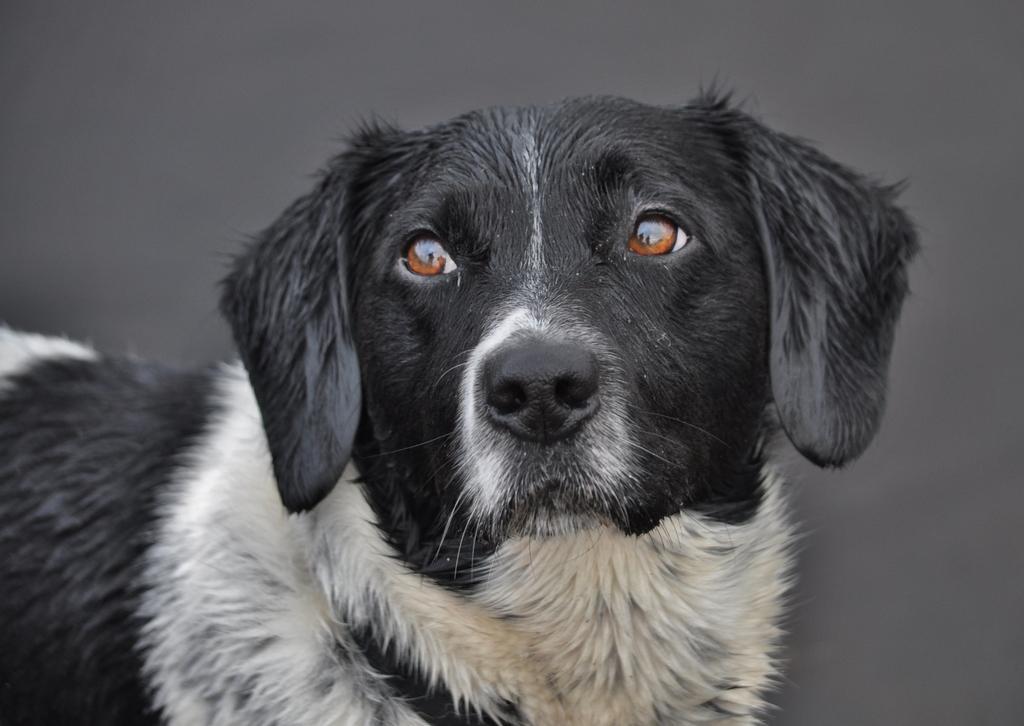How would you summarize this image in a sentence or two? In this image we can see a dog, and the background is gray in color. 